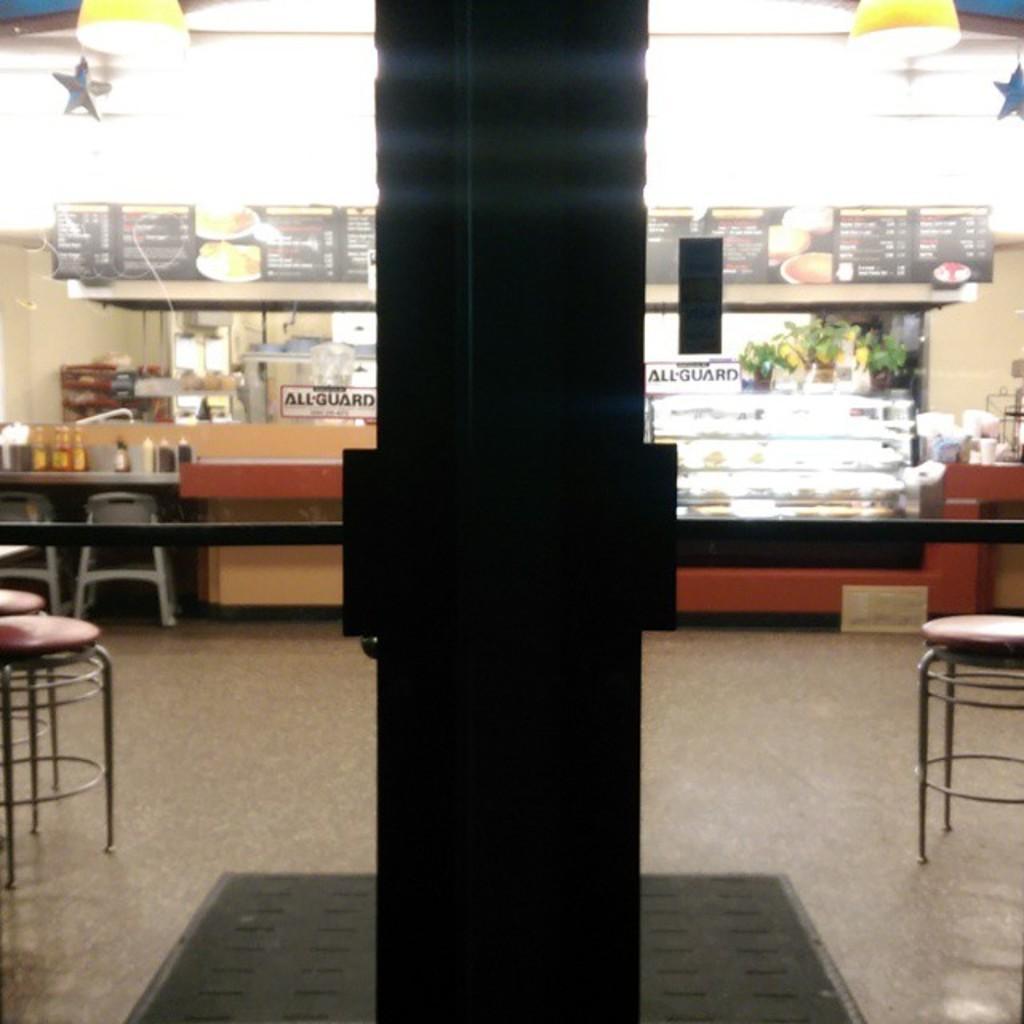How would you summarize this image in a sentence or two? This picture is taken inside the room. In this image, in the middle, we can see a black color pillar. On the left side, we can see tables and chairs, on the table, we can see a plate with some bottles. On the right side, we can see tables and chairs. In the background, we can see a glass table with some food items and a board with some text written on it. At the top, we can see a roof with few lights, at the bottom, we can see a mat. 